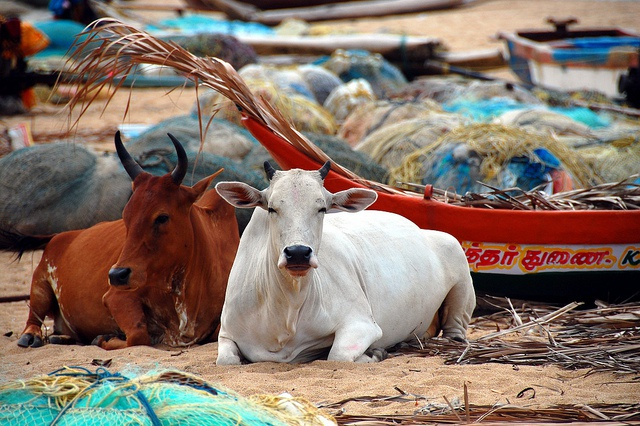Describe the objects in this image and their specific colors. I can see cow in gray, lightgray, and darkgray tones, cow in gray, maroon, black, and brown tones, boat in gray, maroon, black, and brown tones, boat in gray, darkgray, black, and lightgray tones, and boat in gray, lightgray, black, darkgray, and maroon tones in this image. 